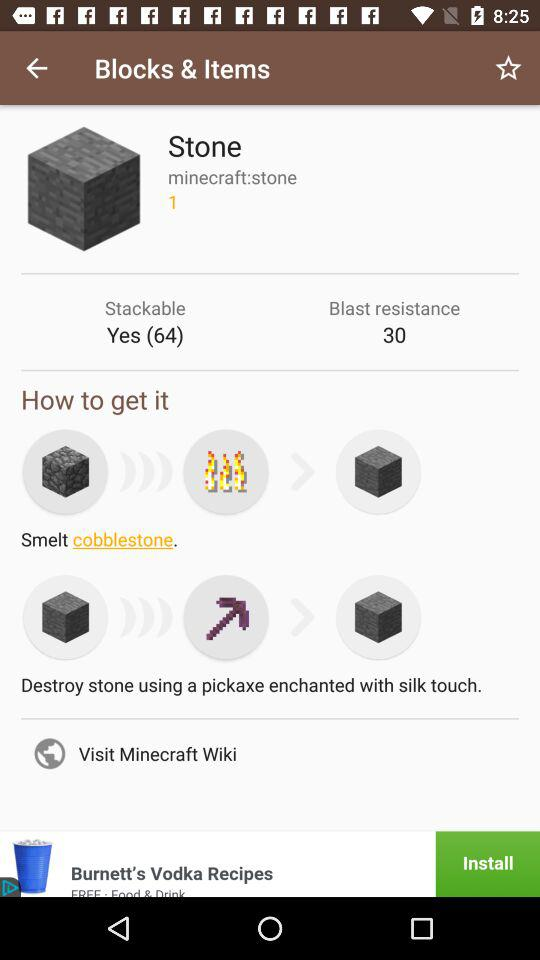What is the count of "Stone"? The count of "Stone" is 1. 